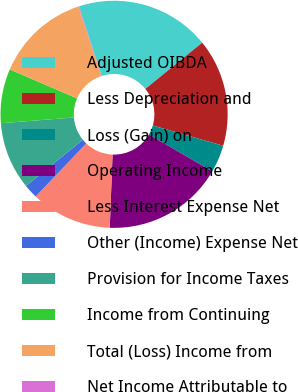<chart> <loc_0><loc_0><loc_500><loc_500><pie_chart><fcel>Adjusted OIBDA<fcel>Less Depreciation and<fcel>Loss (Gain) on<fcel>Operating Income<fcel>Less Interest Expense Net<fcel>Other (Income) Expense Net<fcel>Provision for Income Taxes<fcel>Income from Continuing<fcel>Total (Loss) Income from<fcel>Net Income Attributable to<nl><fcel>19.14%<fcel>15.33%<fcel>3.91%<fcel>17.23%<fcel>11.52%<fcel>2.0%<fcel>9.62%<fcel>7.72%<fcel>13.43%<fcel>0.1%<nl></chart> 